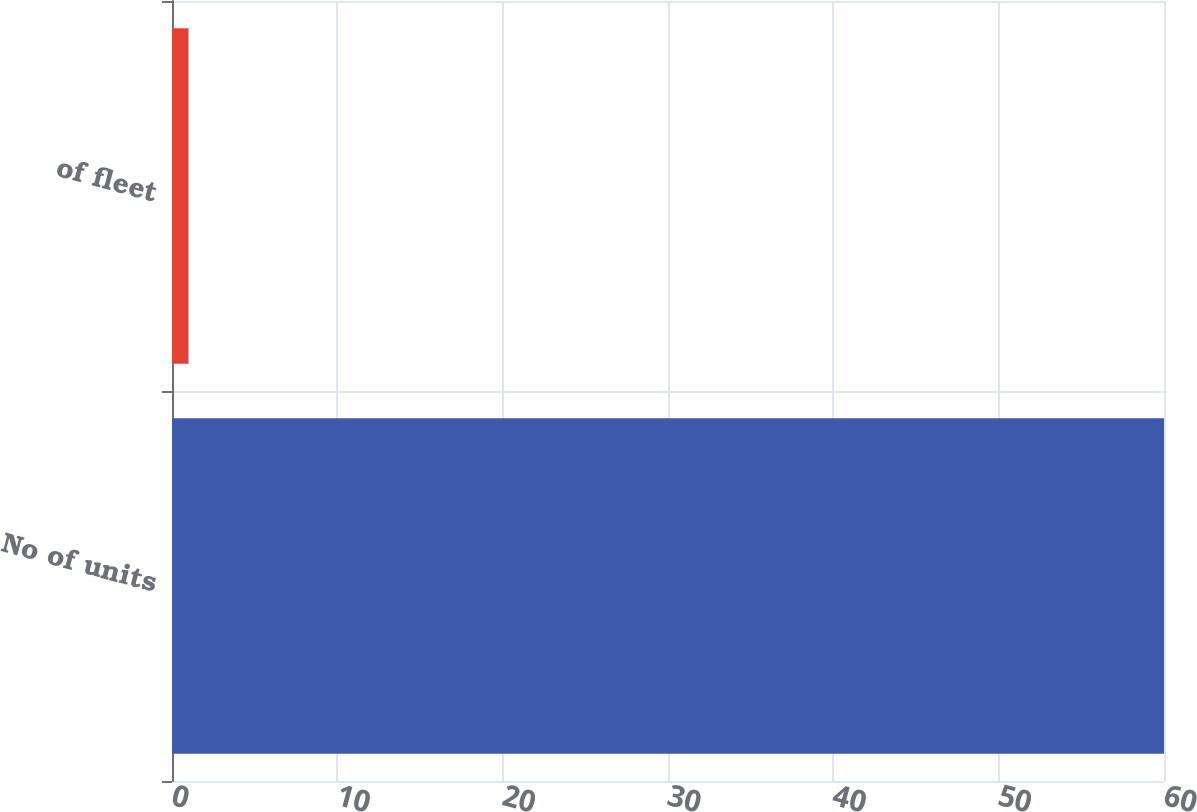Convert chart. <chart><loc_0><loc_0><loc_500><loc_500><bar_chart><fcel>No of units<fcel>of fleet<nl><fcel>60<fcel>1<nl></chart> 